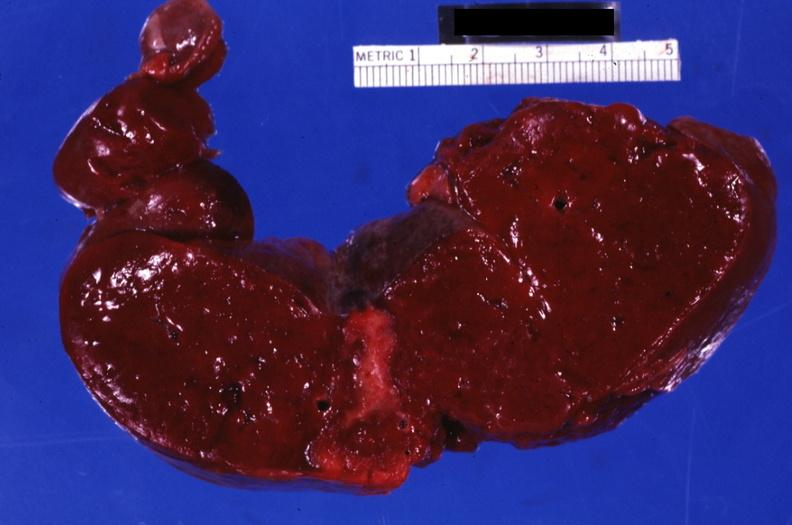how does this image show section?
Answer the question using a single word or phrase. Through spleen with large well shown healing infarct 